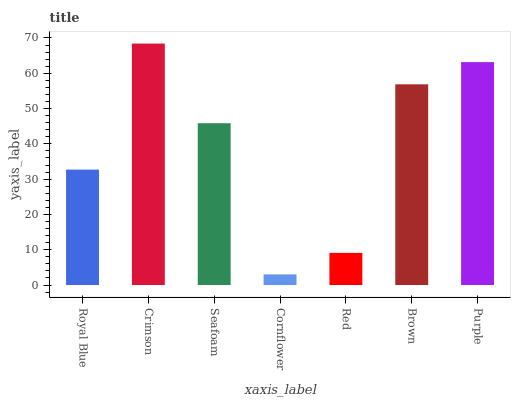Is Cornflower the minimum?
Answer yes or no. Yes. Is Crimson the maximum?
Answer yes or no. Yes. Is Seafoam the minimum?
Answer yes or no. No. Is Seafoam the maximum?
Answer yes or no. No. Is Crimson greater than Seafoam?
Answer yes or no. Yes. Is Seafoam less than Crimson?
Answer yes or no. Yes. Is Seafoam greater than Crimson?
Answer yes or no. No. Is Crimson less than Seafoam?
Answer yes or no. No. Is Seafoam the high median?
Answer yes or no. Yes. Is Seafoam the low median?
Answer yes or no. Yes. Is Red the high median?
Answer yes or no. No. Is Royal Blue the low median?
Answer yes or no. No. 